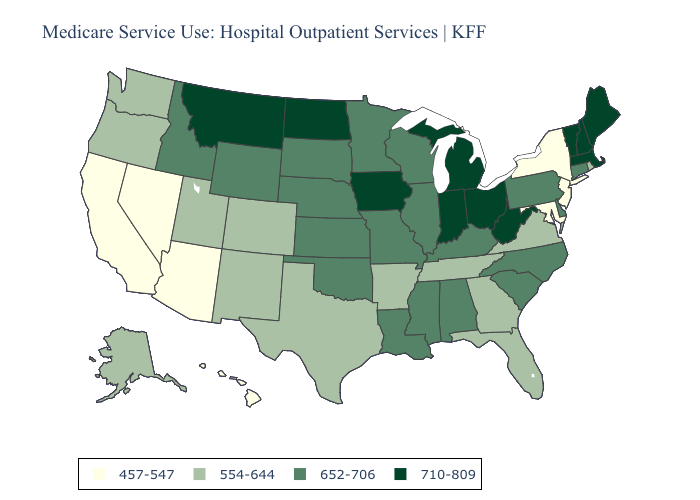What is the value of Georgia?
Give a very brief answer. 554-644. Does the first symbol in the legend represent the smallest category?
Give a very brief answer. Yes. Does Washington have a higher value than Kentucky?
Answer briefly. No. Among the states that border Indiana , does Michigan have the lowest value?
Concise answer only. No. What is the value of New York?
Give a very brief answer. 457-547. Name the states that have a value in the range 554-644?
Give a very brief answer. Alaska, Arkansas, Colorado, Florida, Georgia, New Mexico, Oregon, Rhode Island, Tennessee, Texas, Utah, Virginia, Washington. Name the states that have a value in the range 710-809?
Answer briefly. Indiana, Iowa, Maine, Massachusetts, Michigan, Montana, New Hampshire, North Dakota, Ohio, Vermont, West Virginia. What is the lowest value in the USA?
Short answer required. 457-547. Which states have the lowest value in the Northeast?
Keep it brief. New Jersey, New York. Name the states that have a value in the range 652-706?
Answer briefly. Alabama, Connecticut, Delaware, Idaho, Illinois, Kansas, Kentucky, Louisiana, Minnesota, Mississippi, Missouri, Nebraska, North Carolina, Oklahoma, Pennsylvania, South Carolina, South Dakota, Wisconsin, Wyoming. Does Michigan have the lowest value in the MidWest?
Keep it brief. No. Name the states that have a value in the range 554-644?
Short answer required. Alaska, Arkansas, Colorado, Florida, Georgia, New Mexico, Oregon, Rhode Island, Tennessee, Texas, Utah, Virginia, Washington. What is the value of Wyoming?
Short answer required. 652-706. Does North Carolina have the lowest value in the USA?
Be succinct. No. Among the states that border New Jersey , which have the lowest value?
Short answer required. New York. 